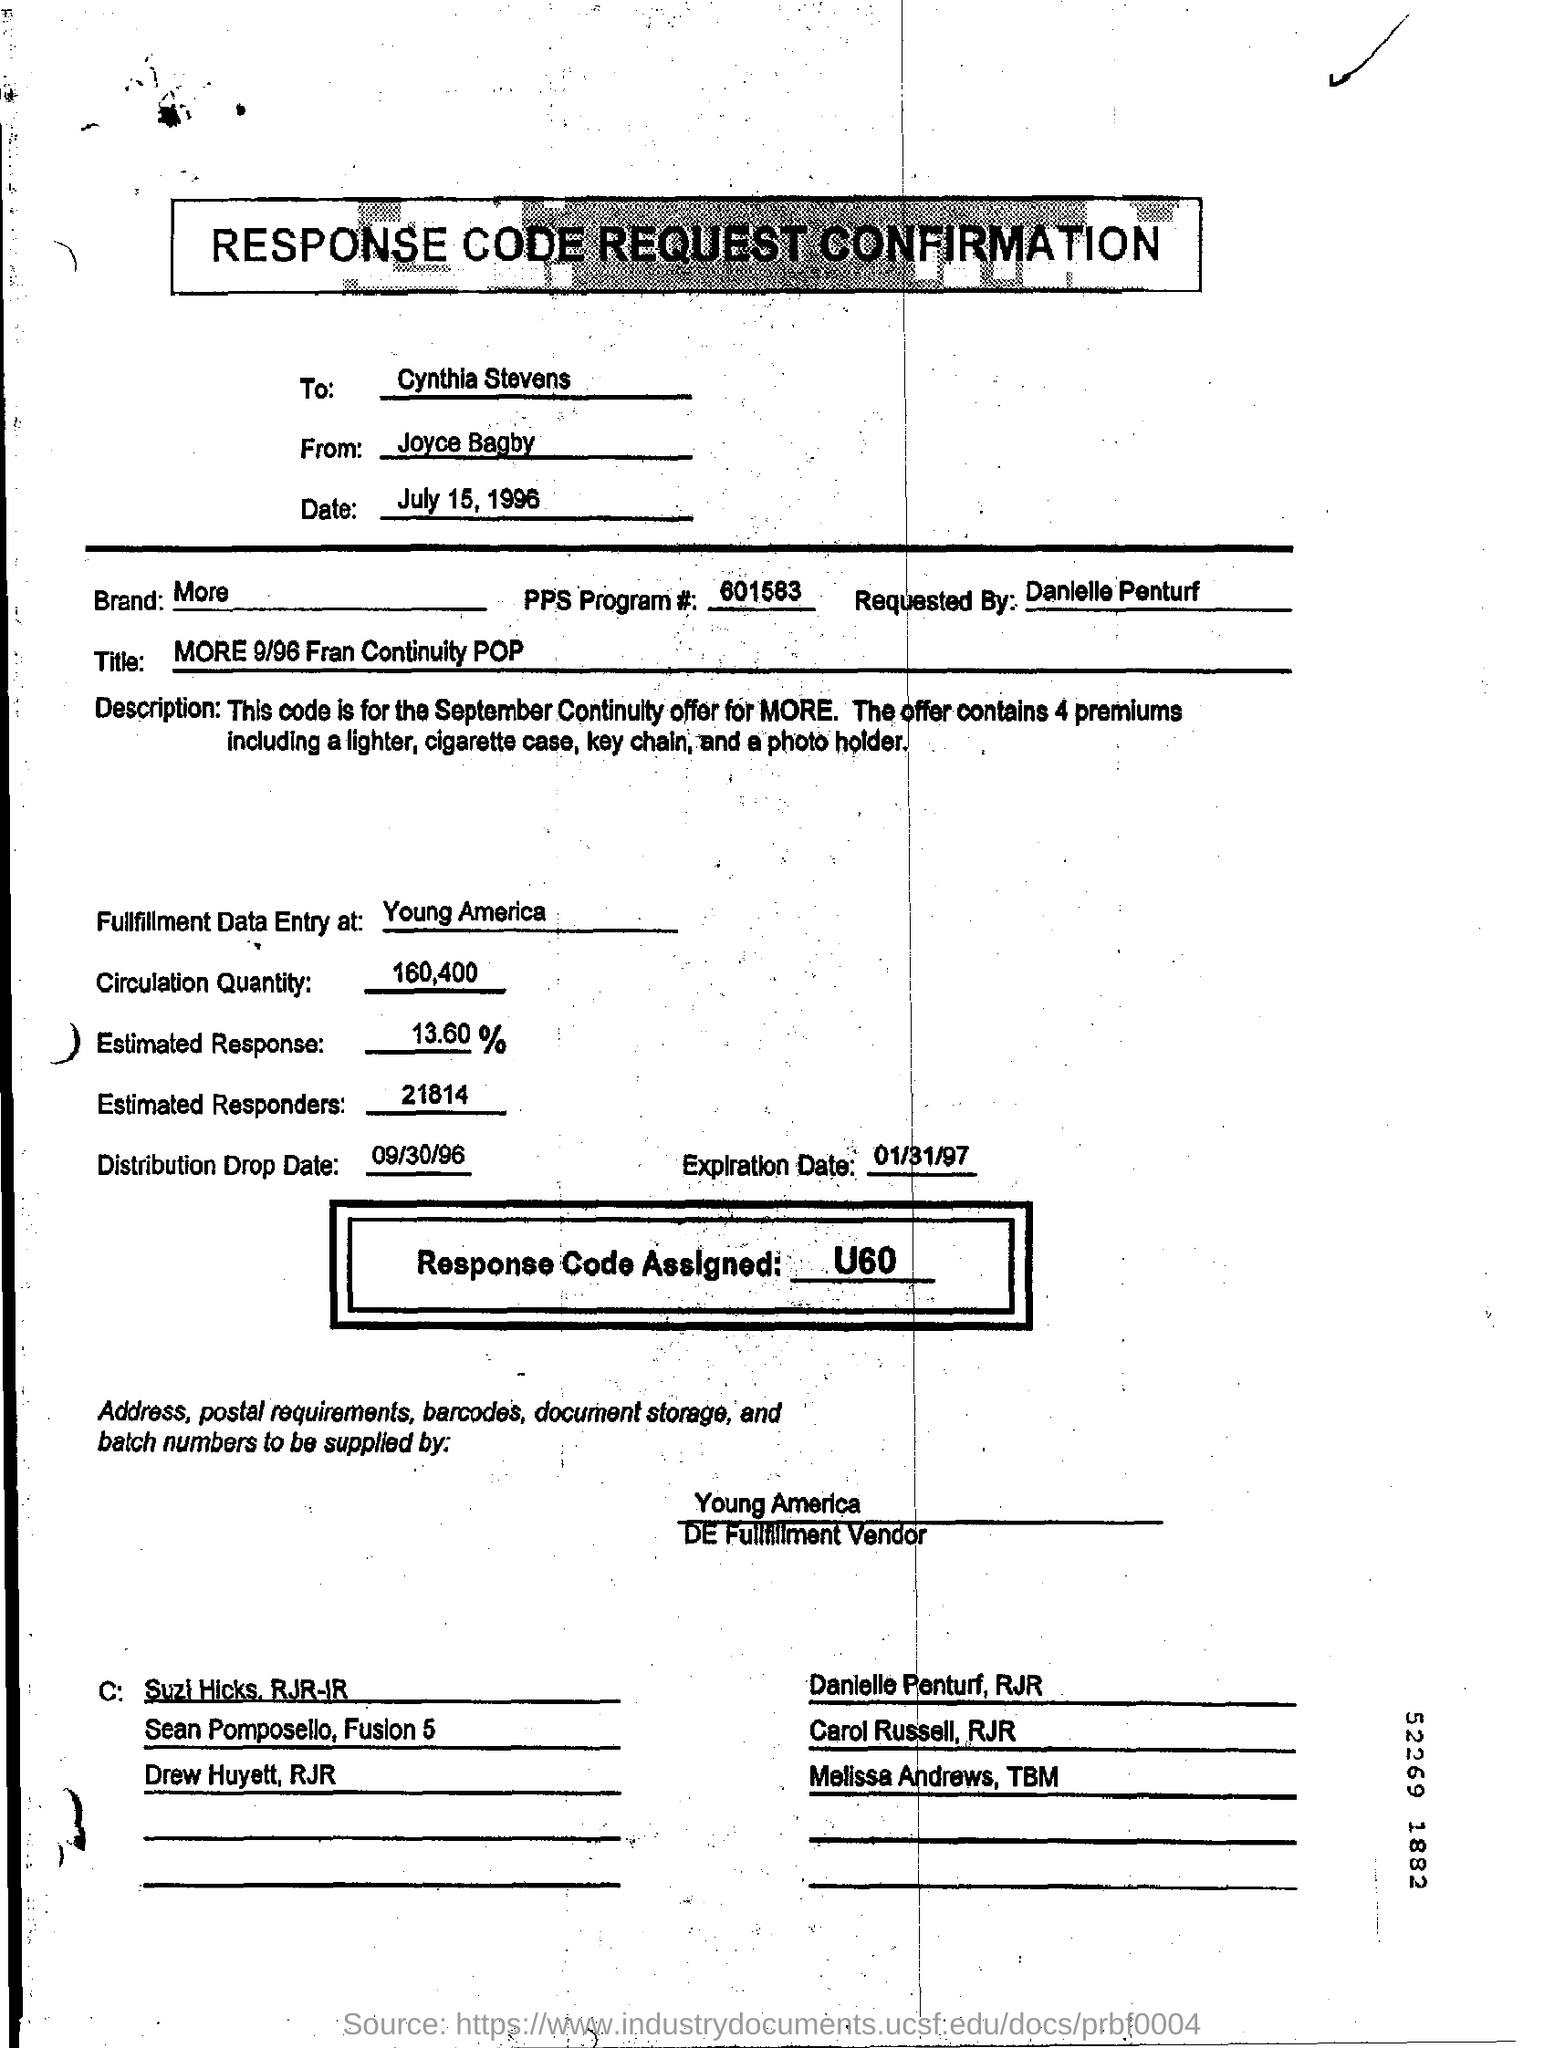Draw attention to some important aspects in this diagram. Joyce Bagby sent this. The title field contains the written text 'MORE 9/96 Fran Continuity POP.' The specified brand is mentioned in the form. The Response Code Assigned field contains the value U60. The recipient of the message is Cynthia Stevens. 